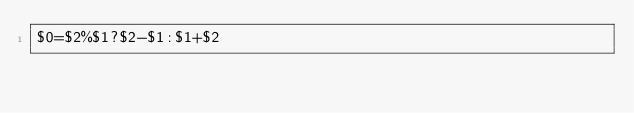<code> <loc_0><loc_0><loc_500><loc_500><_Awk_>$0=$2%$1?$2-$1:$1+$2</code> 